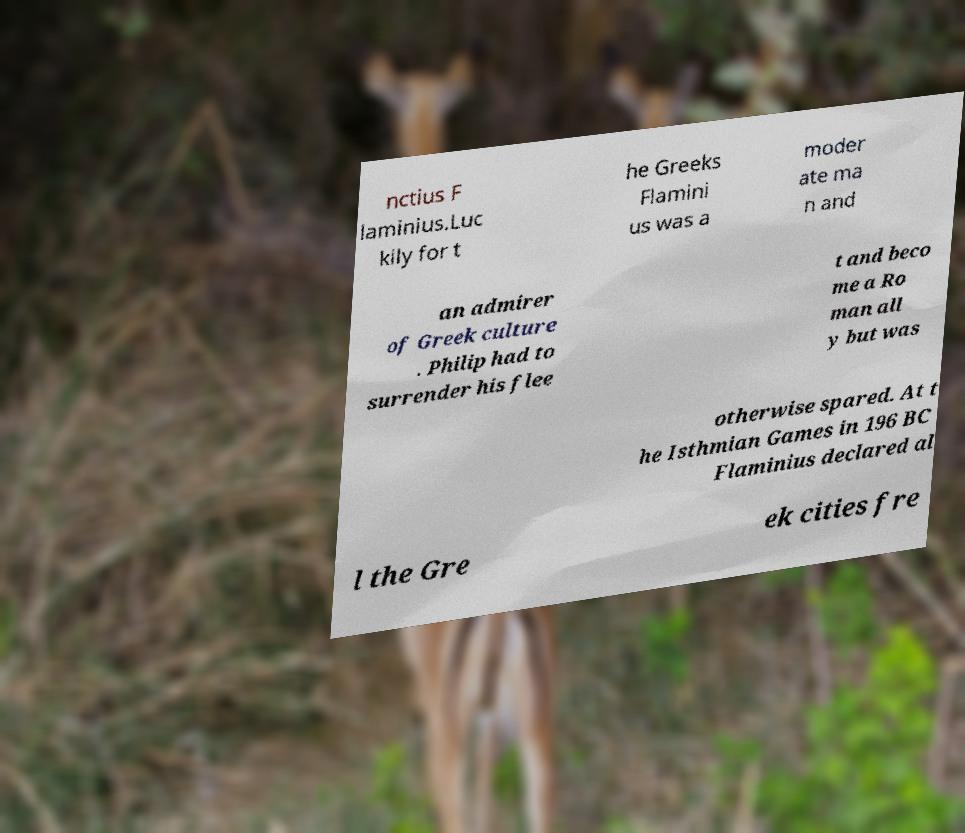Can you read and provide the text displayed in the image?This photo seems to have some interesting text. Can you extract and type it out for me? nctius F laminius.Luc kily for t he Greeks Flamini us was a moder ate ma n and an admirer of Greek culture . Philip had to surrender his flee t and beco me a Ro man all y but was otherwise spared. At t he Isthmian Games in 196 BC Flaminius declared al l the Gre ek cities fre 